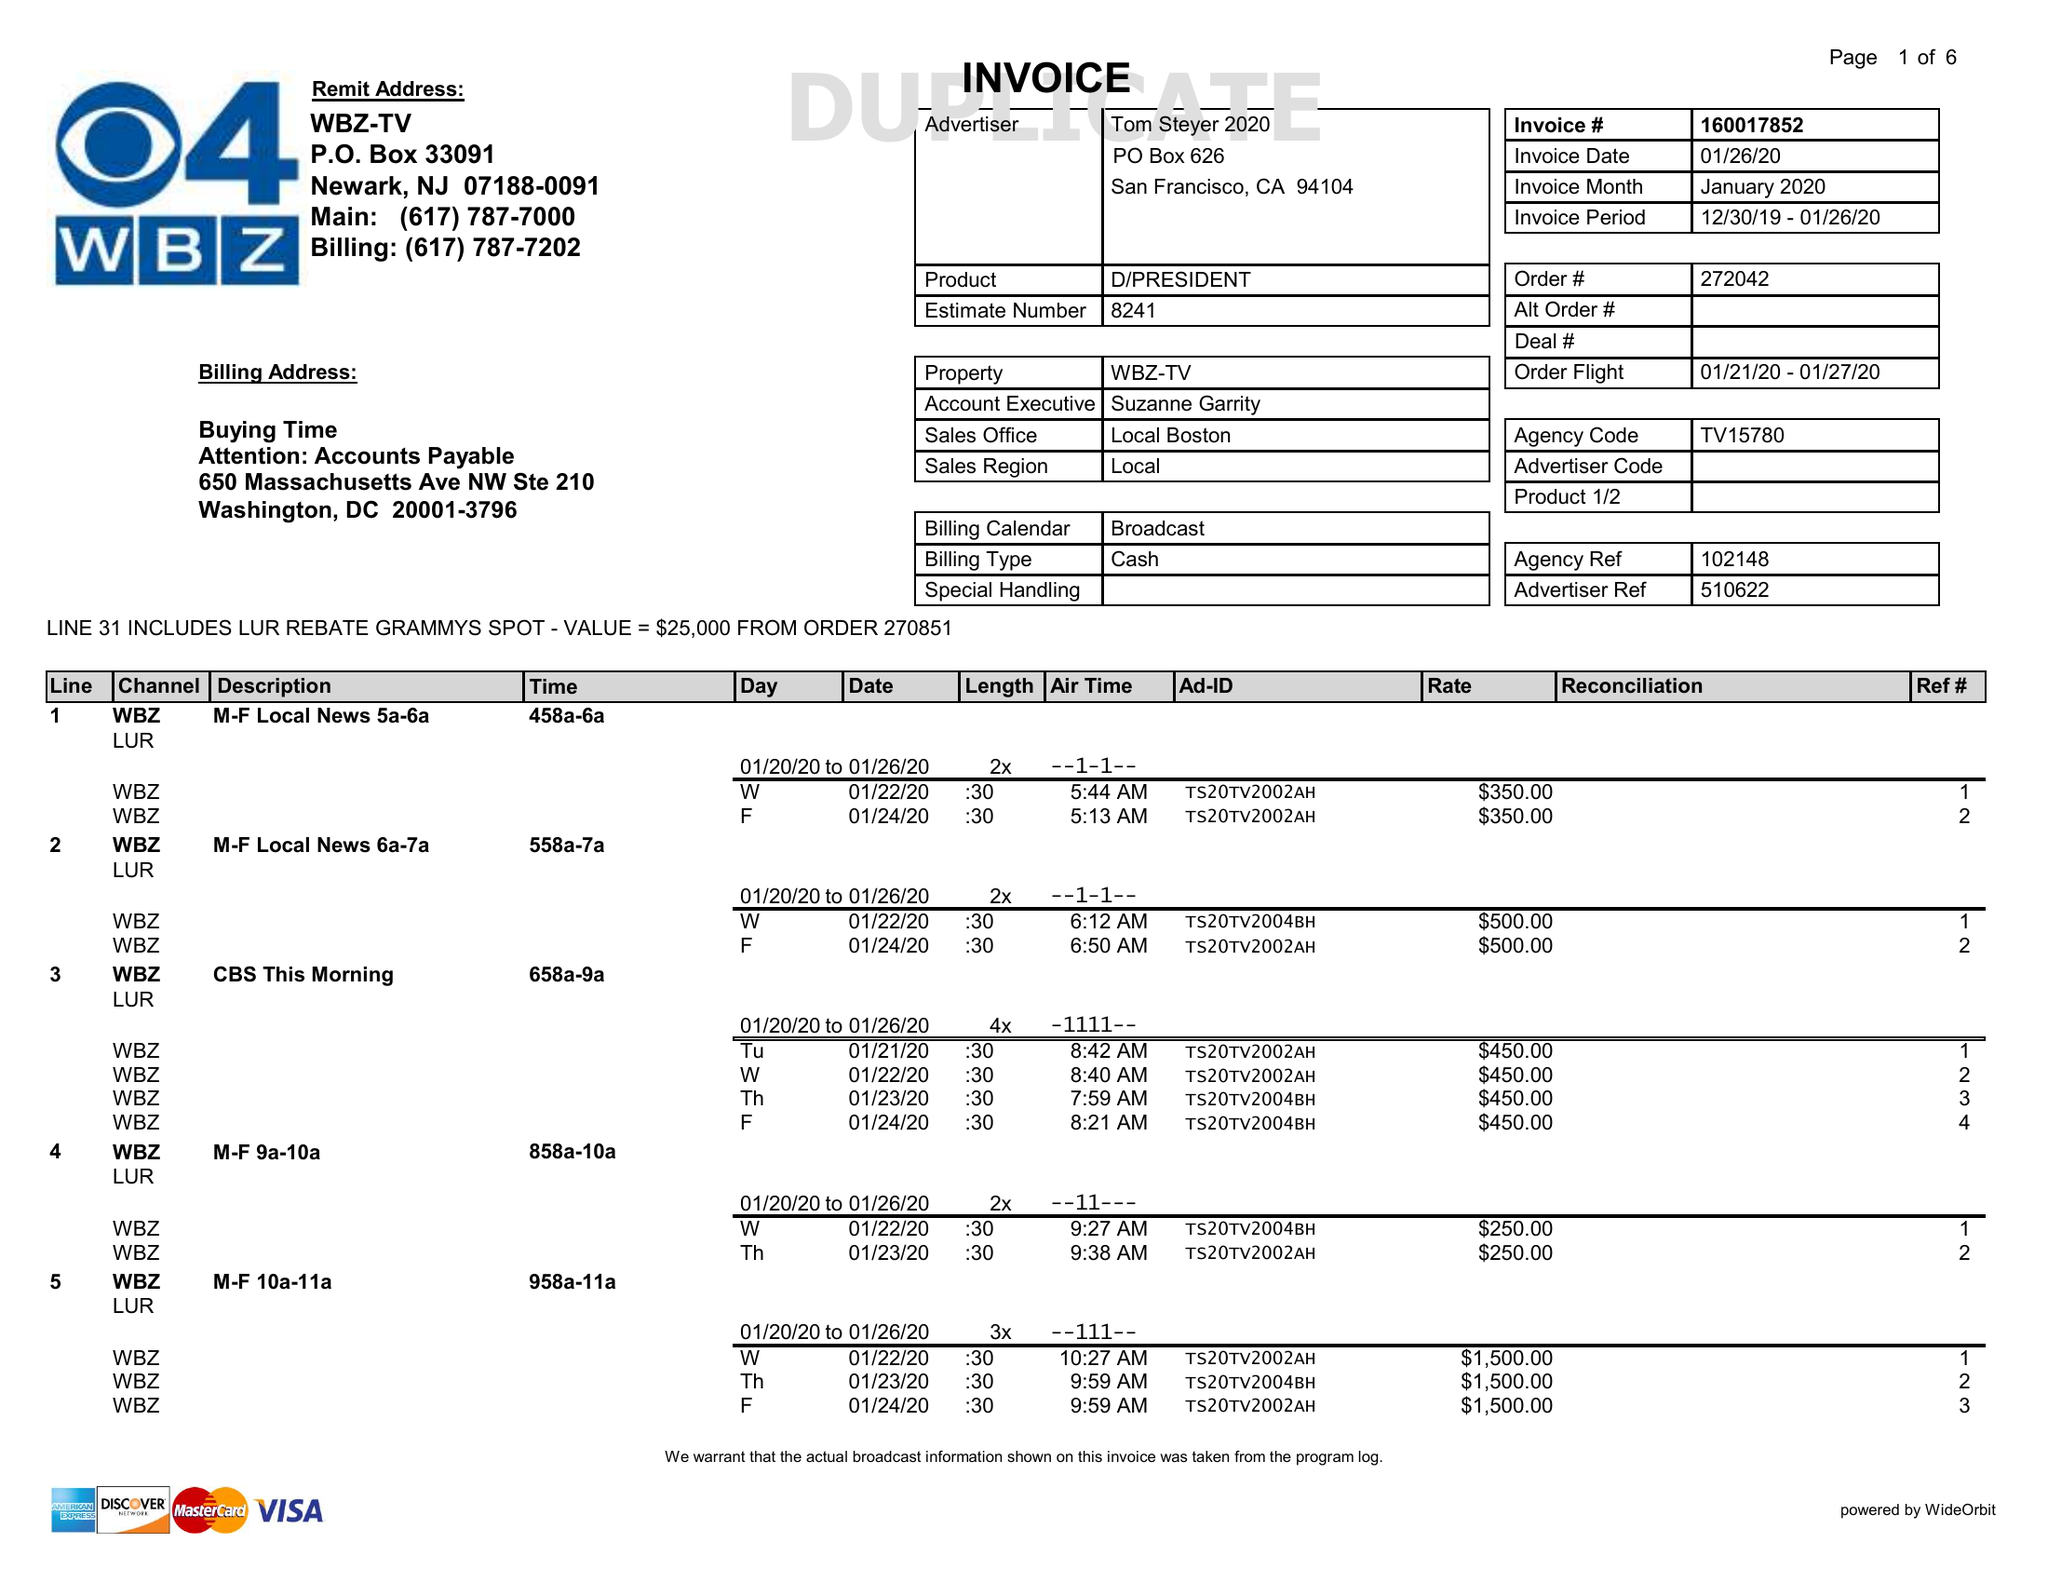What is the value for the flight_to?
Answer the question using a single word or phrase. 01/27/20 